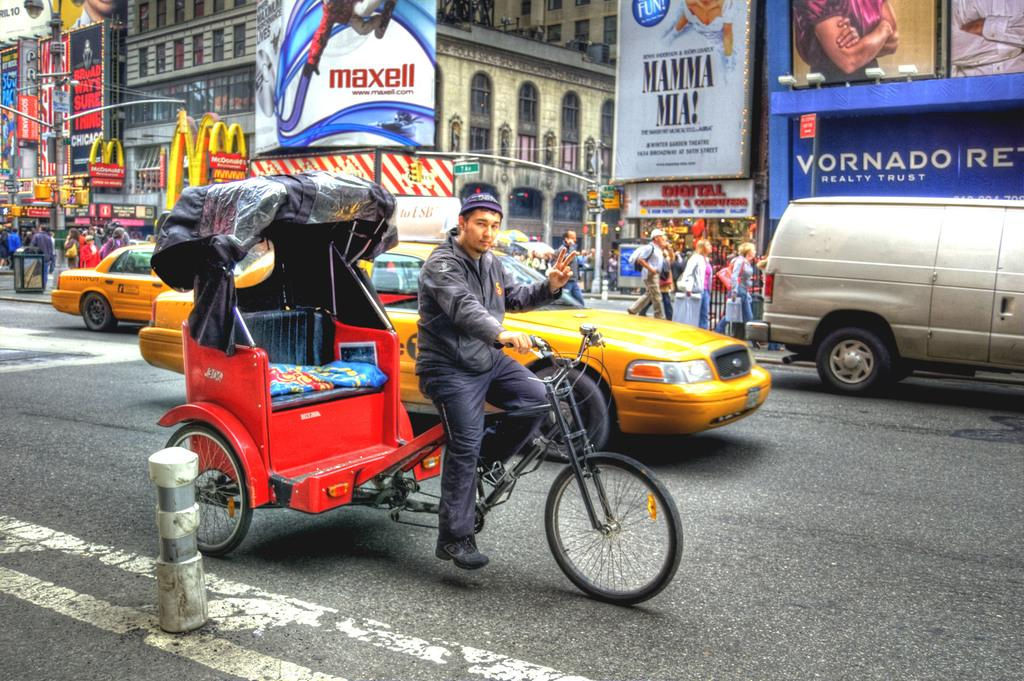<image>
Provide a brief description of the given image. A large ad for Mamma Mia is in the background of a busy street. 